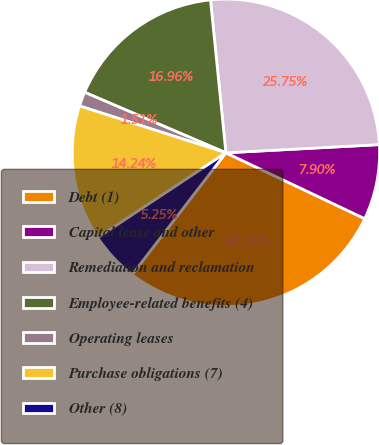Convert chart. <chart><loc_0><loc_0><loc_500><loc_500><pie_chart><fcel>Debt (1)<fcel>Capital lease and other<fcel>Remediation and reclamation<fcel>Employee-related benefits (4)<fcel>Operating leases<fcel>Purchase obligations (7)<fcel>Other (8)<nl><fcel>28.39%<fcel>7.9%<fcel>25.75%<fcel>16.96%<fcel>1.51%<fcel>14.24%<fcel>5.25%<nl></chart> 